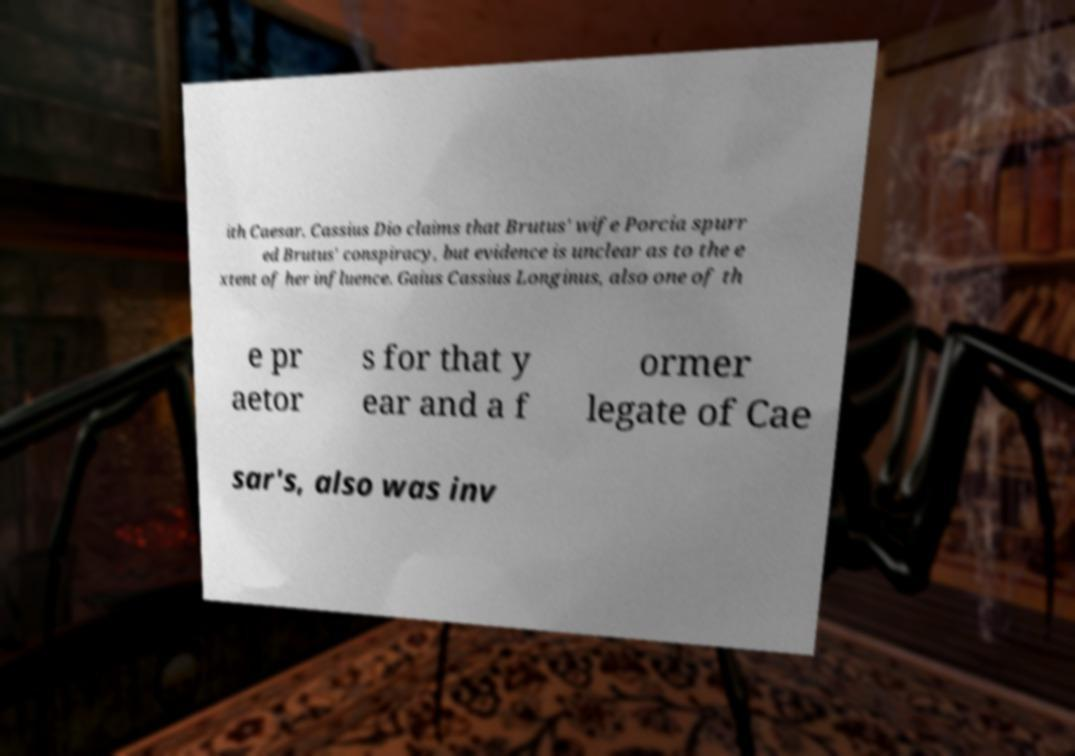Please identify and transcribe the text found in this image. ith Caesar. Cassius Dio claims that Brutus' wife Porcia spurr ed Brutus' conspiracy, but evidence is unclear as to the e xtent of her influence. Gaius Cassius Longinus, also one of th e pr aetor s for that y ear and a f ormer legate of Cae sar's, also was inv 